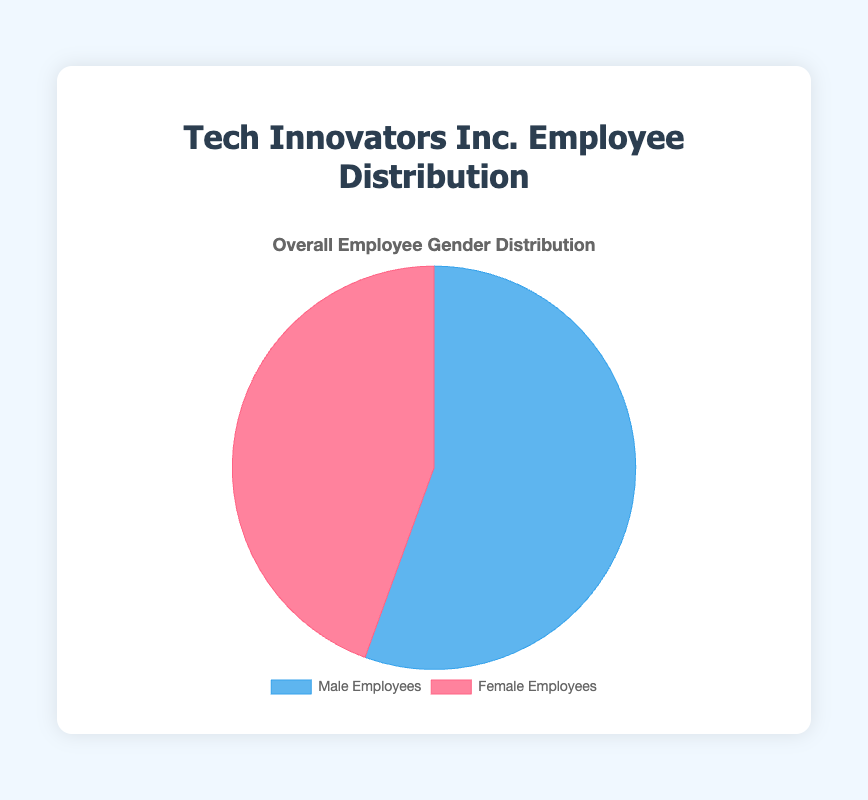What percentage of employees are male? The pie chart shows the distribution of male and female employees. To find the percentage of male employees, divide the number of male employees (200) by the total number of employees (200 + 160), then multiply by 100. This is (200 / (200 + 160)) * 100 = 55.6%.
Answer: 55.6% Which gender has fewer employees in the company? By observing the pie chart, we see two segments: one for male employees and one for female employees. The number of female employees (160) is less than the number of male employees (200).
Answer: Female How many more male employees are there than female employees? The pie chart has counts of male and female employees. Subtract the number of female employees from male employees to find the difference: 200 - 160 = 40.
Answer: 40 Is the number of female employees more than 40% of the total employees? To check this, we find the percentage of female employees by dividing the number of female employees (160) by the total number of employees (360), then multiplying by 100. This is (160 / 360) * 100 ≈ 44.4%. Since 44.4% is more than 40%, the statement is true.
Answer: Yes What is the ratio of male to female employees? To determine the ratio of male to female employees, divide the number of male employees by the number of female employees. Therefore, the ratio is 200 / 160 = 1.25.
Answer: 1.25:1 What percentage of the employees are female? The total number of employees is 360. To find the percentage of female employees, divide the number of female employees (160) by the total number of employees (360) and multiply by 100. This is (160 / 360) * 100 ≈ 44.4%.
Answer: 44.4% Do male employees represent more than half of the total employees? To determine this, observe the pie chart and see if the male segment is more than half. Since male employees are 55.6% of the total (200 out of 360), which is more than half (50%), the statement is true.
Answer: Yes If another 40 female employees are hired, what would be the new percentage of female employees? Adding 40 to the current number of female employees gives 160 + 40 = 200. The new total employees would be 200 (males) + 200 (females) = 400. The new percentage of female employees is (200 / 400) * 100 = 50%.
Answer: 50% 